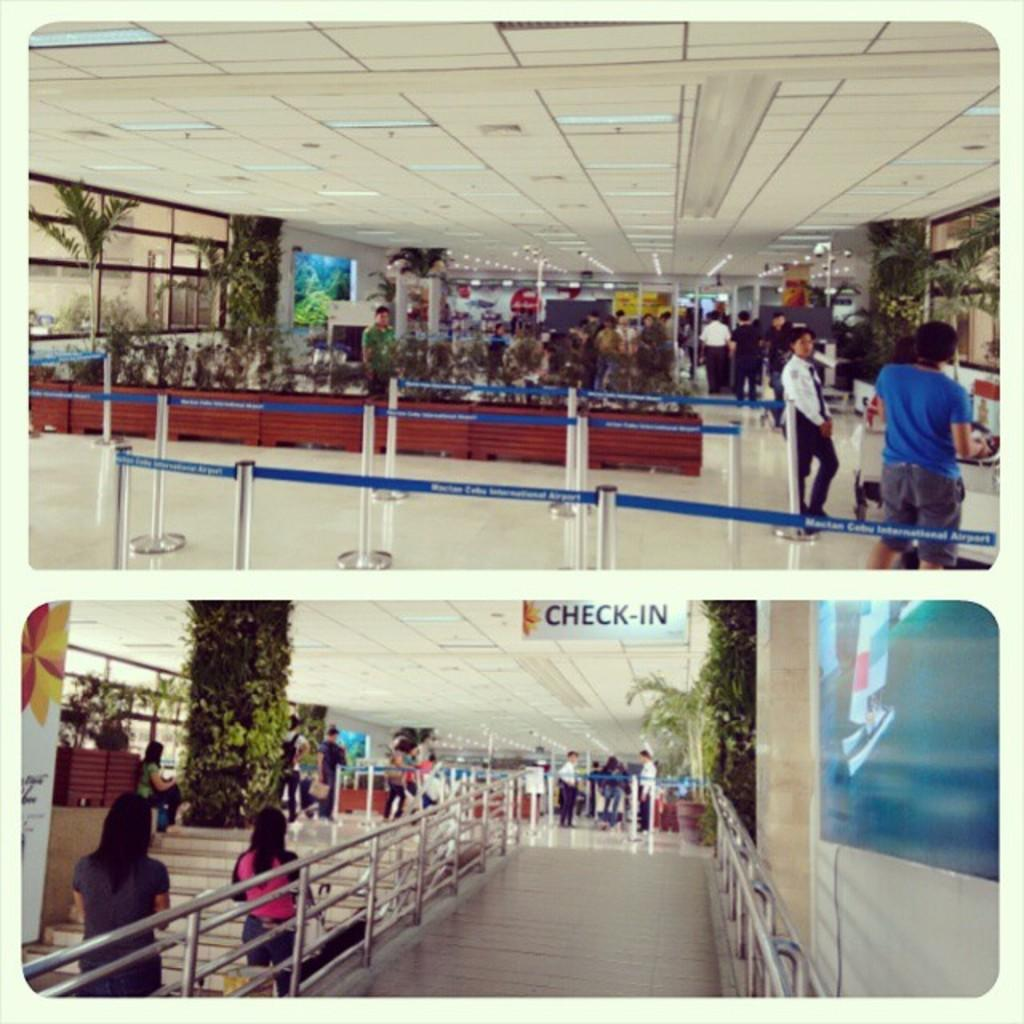What can be seen in the foreground of the image? There are trees in the foreground of the image. What safety features are present in the image? Safety poles and railing are visible in the image. What architectural element is present in the image? There is a ceiling in the image. What type of surface is visible in the image? Few boards and the floor are visible in the image. What type of display is present in the image? Screens are present in the image. What activities are people engaged in within the image? People are walking and standing in the image. What is the structure of the stairs in the image? Stairs are visible in the image. How many bees can be seen flying around the trees in the image? There are no bees visible in the image; only trees are present in the foreground. What type of weather is depicted in the image, given the presence of the sun? There is no sun visible in the image, so it cannot be determined from the image. How many houses are visible in the image? There are no houses present in the image. 